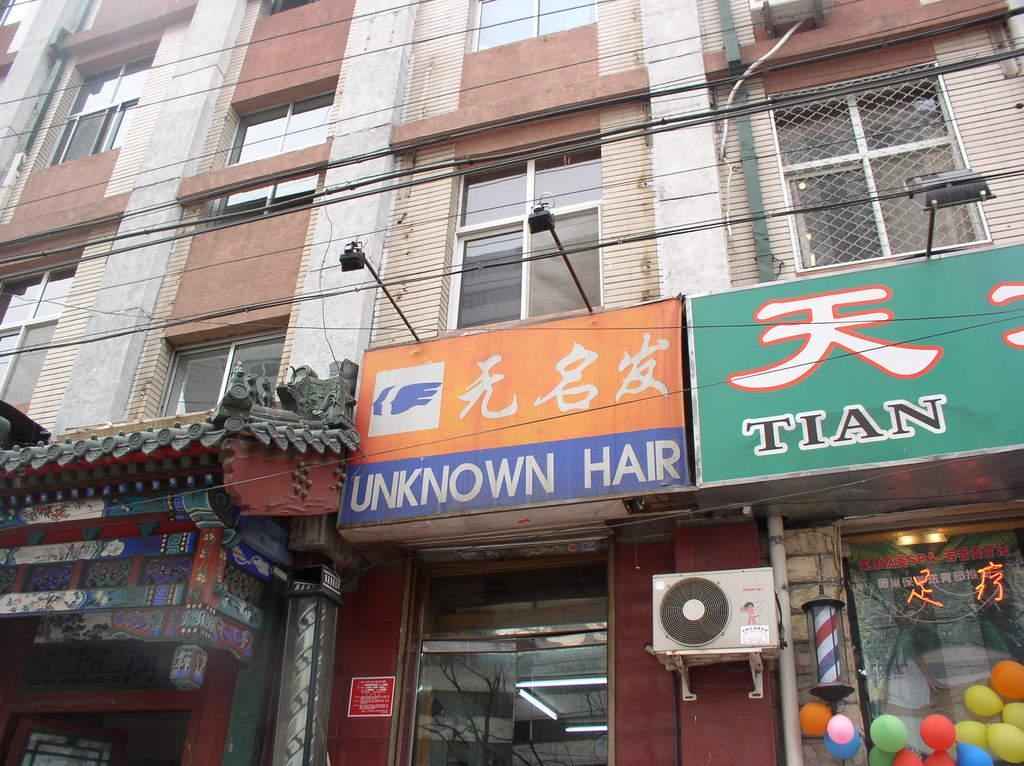Describe this image in one or two sentences. In this picture there is a building and there are boards on the building and there is an air conditioner and there is a pipe on the wall and there are lights inside the building. At the bottom right there are balloons and there is text on the boards. 